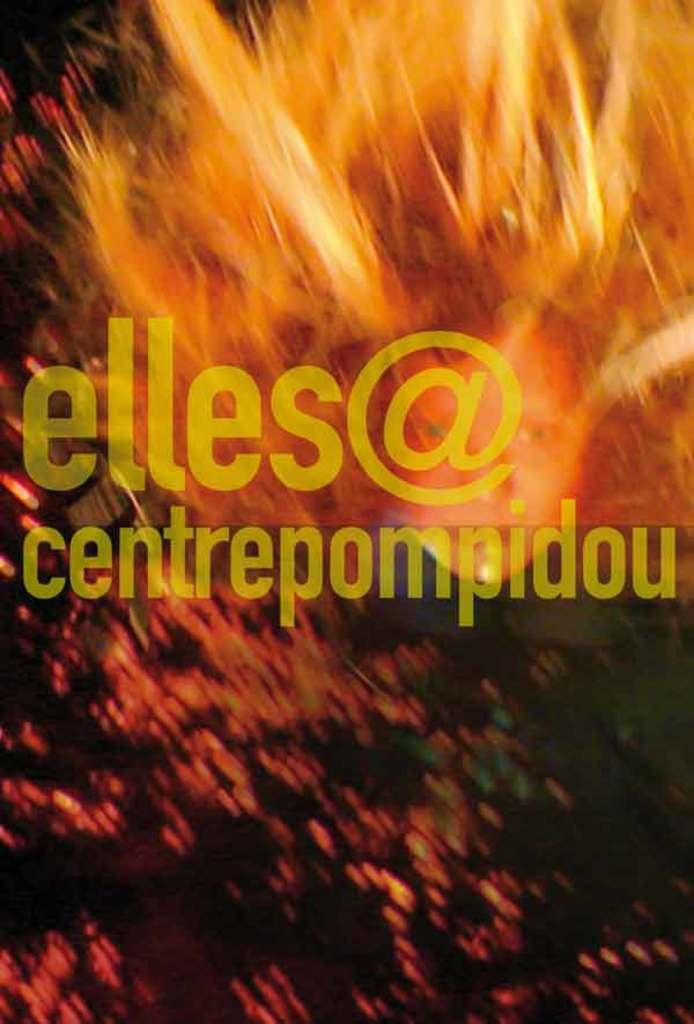<image>
Relay a brief, clear account of the picture shown. An advertisement for elles@centrepompidou with a graphic of a fire behind it. 